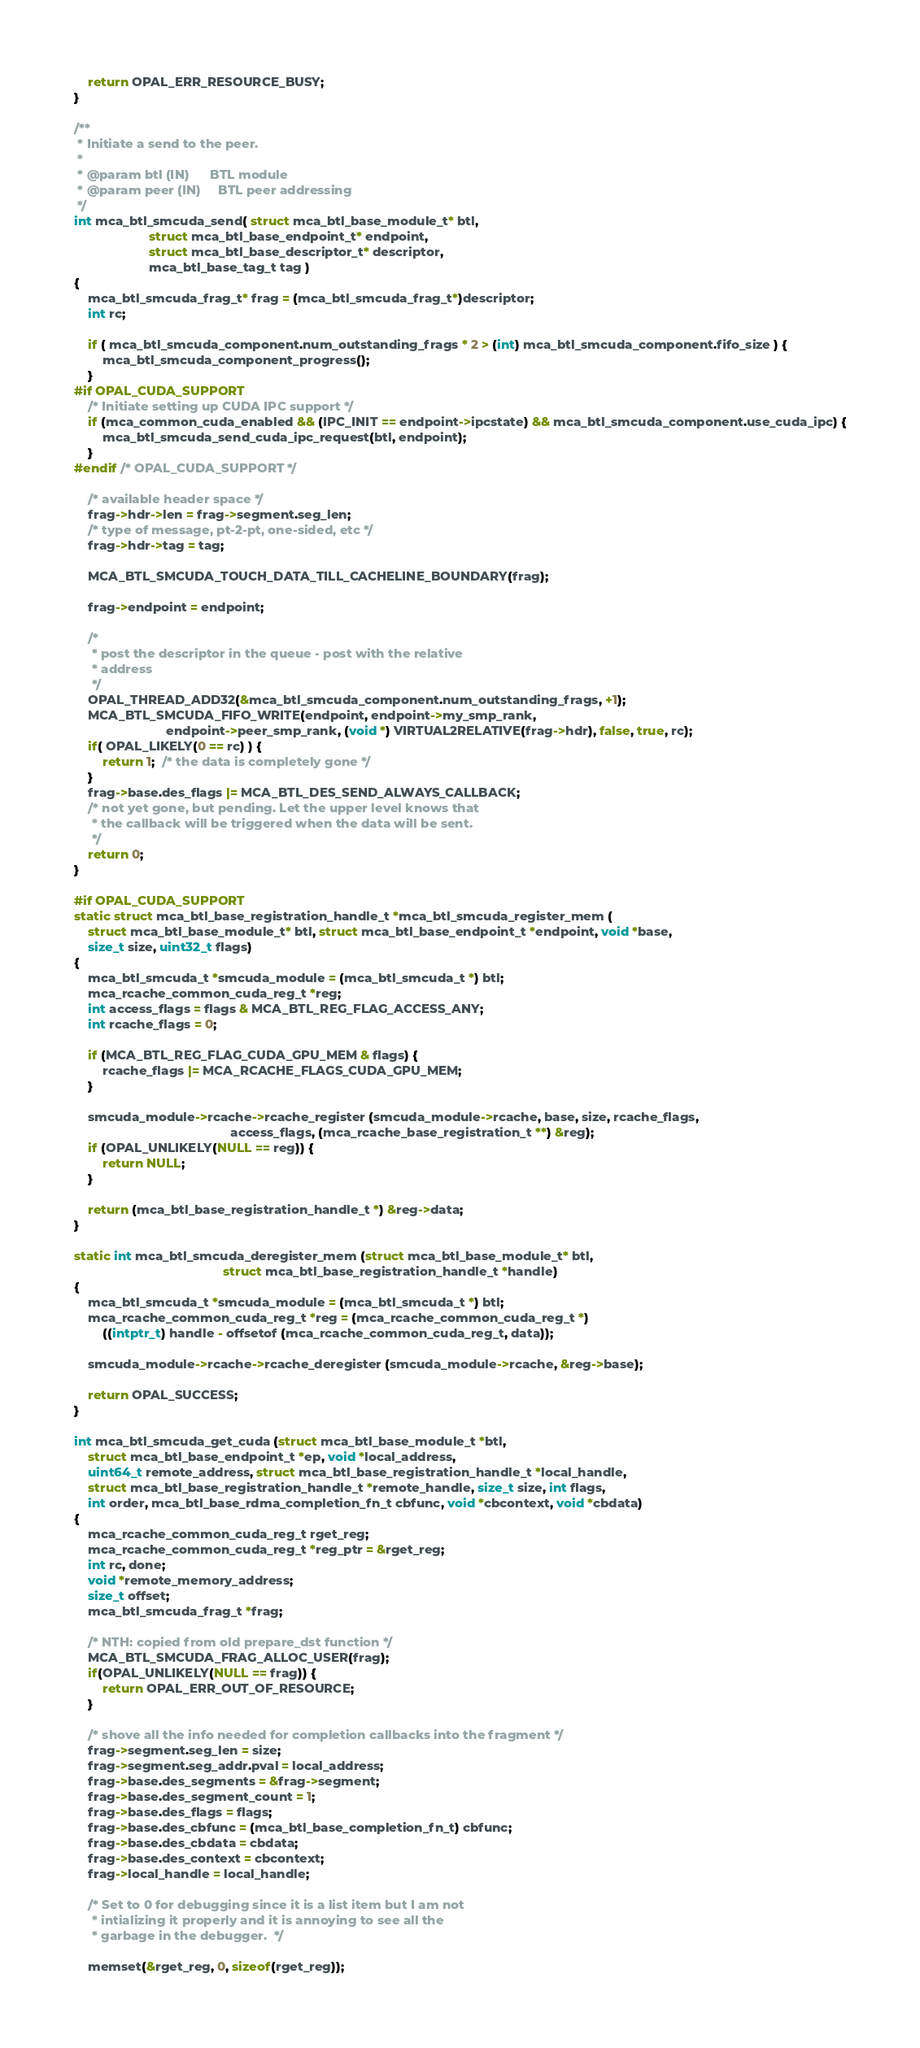Convert code to text. <code><loc_0><loc_0><loc_500><loc_500><_C_>    return OPAL_ERR_RESOURCE_BUSY;
}

/**
 * Initiate a send to the peer.
 *
 * @param btl (IN)      BTL module
 * @param peer (IN)     BTL peer addressing
 */
int mca_btl_smcuda_send( struct mca_btl_base_module_t* btl,
                     struct mca_btl_base_endpoint_t* endpoint,
                     struct mca_btl_base_descriptor_t* descriptor,
                     mca_btl_base_tag_t tag )
{
    mca_btl_smcuda_frag_t* frag = (mca_btl_smcuda_frag_t*)descriptor;
    int rc;

    if ( mca_btl_smcuda_component.num_outstanding_frags * 2 > (int) mca_btl_smcuda_component.fifo_size ) {
        mca_btl_smcuda_component_progress();
    }
#if OPAL_CUDA_SUPPORT
    /* Initiate setting up CUDA IPC support */
    if (mca_common_cuda_enabled && (IPC_INIT == endpoint->ipcstate) && mca_btl_smcuda_component.use_cuda_ipc) {
        mca_btl_smcuda_send_cuda_ipc_request(btl, endpoint);
    }
#endif /* OPAL_CUDA_SUPPORT */

    /* available header space */
    frag->hdr->len = frag->segment.seg_len;
    /* type of message, pt-2-pt, one-sided, etc */
    frag->hdr->tag = tag;

    MCA_BTL_SMCUDA_TOUCH_DATA_TILL_CACHELINE_BOUNDARY(frag);

    frag->endpoint = endpoint;

    /*
     * post the descriptor in the queue - post with the relative
     * address
     */
    OPAL_THREAD_ADD32(&mca_btl_smcuda_component.num_outstanding_frags, +1);
    MCA_BTL_SMCUDA_FIFO_WRITE(endpoint, endpoint->my_smp_rank,
                          endpoint->peer_smp_rank, (void *) VIRTUAL2RELATIVE(frag->hdr), false, true, rc);
    if( OPAL_LIKELY(0 == rc) ) {
        return 1;  /* the data is completely gone */
    }
    frag->base.des_flags |= MCA_BTL_DES_SEND_ALWAYS_CALLBACK;
    /* not yet gone, but pending. Let the upper level knows that
     * the callback will be triggered when the data will be sent.
     */
    return 0;
}

#if OPAL_CUDA_SUPPORT
static struct mca_btl_base_registration_handle_t *mca_btl_smcuda_register_mem (
    struct mca_btl_base_module_t* btl, struct mca_btl_base_endpoint_t *endpoint, void *base,
    size_t size, uint32_t flags)
{
    mca_btl_smcuda_t *smcuda_module = (mca_btl_smcuda_t *) btl;
    mca_rcache_common_cuda_reg_t *reg;
    int access_flags = flags & MCA_BTL_REG_FLAG_ACCESS_ANY;
    int rcache_flags = 0;

    if (MCA_BTL_REG_FLAG_CUDA_GPU_MEM & flags) {
        rcache_flags |= MCA_RCACHE_FLAGS_CUDA_GPU_MEM;
    }

    smcuda_module->rcache->rcache_register (smcuda_module->rcache, base, size, rcache_flags,
                                            access_flags, (mca_rcache_base_registration_t **) &reg);
    if (OPAL_UNLIKELY(NULL == reg)) {
        return NULL;
    }

    return (mca_btl_base_registration_handle_t *) &reg->data;
}

static int mca_btl_smcuda_deregister_mem (struct mca_btl_base_module_t* btl,
                                          struct mca_btl_base_registration_handle_t *handle)
{
    mca_btl_smcuda_t *smcuda_module = (mca_btl_smcuda_t *) btl;
    mca_rcache_common_cuda_reg_t *reg = (mca_rcache_common_cuda_reg_t *)
        ((intptr_t) handle - offsetof (mca_rcache_common_cuda_reg_t, data));

    smcuda_module->rcache->rcache_deregister (smcuda_module->rcache, &reg->base);

    return OPAL_SUCCESS;
}

int mca_btl_smcuda_get_cuda (struct mca_btl_base_module_t *btl,
    struct mca_btl_base_endpoint_t *ep, void *local_address,
    uint64_t remote_address, struct mca_btl_base_registration_handle_t *local_handle,
    struct mca_btl_base_registration_handle_t *remote_handle, size_t size, int flags,
    int order, mca_btl_base_rdma_completion_fn_t cbfunc, void *cbcontext, void *cbdata)
{
    mca_rcache_common_cuda_reg_t rget_reg;
    mca_rcache_common_cuda_reg_t *reg_ptr = &rget_reg;
    int rc, done;
    void *remote_memory_address;
    size_t offset;
    mca_btl_smcuda_frag_t *frag;

    /* NTH: copied from old prepare_dst function */
    MCA_BTL_SMCUDA_FRAG_ALLOC_USER(frag);
    if(OPAL_UNLIKELY(NULL == frag)) {
        return OPAL_ERR_OUT_OF_RESOURCE;
    }

    /* shove all the info needed for completion callbacks into the fragment */
    frag->segment.seg_len = size;
    frag->segment.seg_addr.pval = local_address;
    frag->base.des_segments = &frag->segment;
    frag->base.des_segment_count = 1;
    frag->base.des_flags = flags;
    frag->base.des_cbfunc = (mca_btl_base_completion_fn_t) cbfunc;
    frag->base.des_cbdata = cbdata;
    frag->base.des_context = cbcontext;
    frag->local_handle = local_handle;

    /* Set to 0 for debugging since it is a list item but I am not
     * intializing it properly and it is annoying to see all the
     * garbage in the debugger.  */

    memset(&rget_reg, 0, sizeof(rget_reg));</code> 